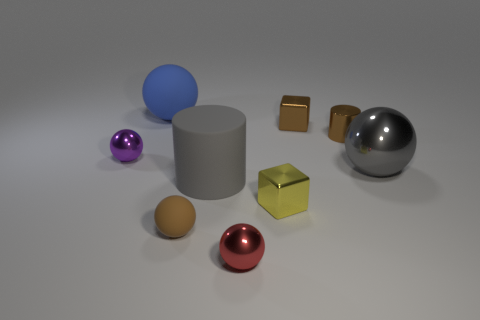Are there any big blue objects made of the same material as the gray cylinder?
Your response must be concise. Yes. There is a gray cylinder that is the same size as the gray metallic ball; what is it made of?
Your answer should be very brief. Rubber. There is a matte thing in front of the large rubber object in front of the ball behind the purple ball; what is its color?
Provide a succinct answer. Brown. Is the shape of the big gray thing that is to the left of the small yellow block the same as the object left of the blue object?
Provide a succinct answer. No. What number of yellow rubber spheres are there?
Your answer should be very brief. 0. The matte ball that is the same size as the gray metallic ball is what color?
Ensure brevity in your answer.  Blue. Does the gray thing that is right of the small brown metallic cylinder have the same material as the small sphere that is to the left of the big blue matte ball?
Your answer should be compact. Yes. There is a gray object that is to the left of the cylinder that is to the right of the red shiny ball; how big is it?
Your response must be concise. Large. There is a block that is behind the gray metallic object; what is its material?
Your answer should be very brief. Metal. What number of objects are big objects that are to the left of the gray metallic sphere or gray objects on the right side of the big gray cylinder?
Offer a very short reply. 3. 